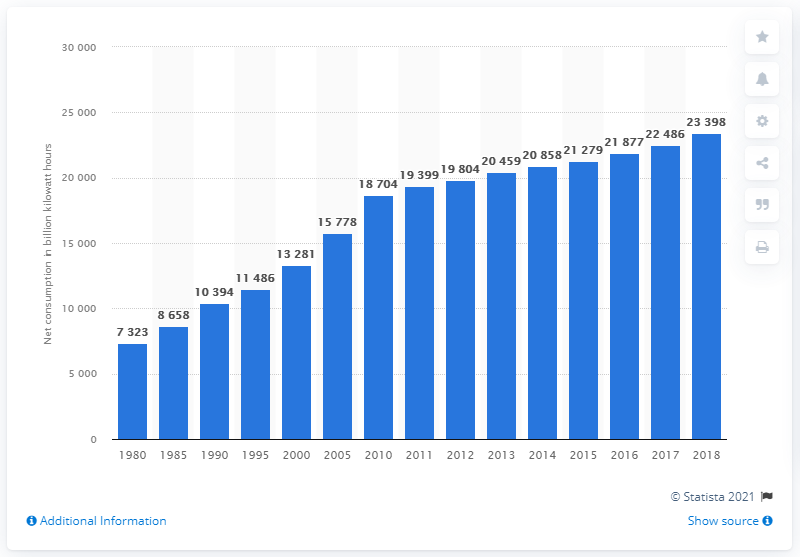How does the trend in the chart reflect changes in the energy sector? The trend in the chart highlights a shift towards higher electricity demand, which signals changes in the energy sector such as increased investment in electricity infrastructure, the development of renewable energy sources, and efforts to improve energy efficiency. It also suggests that there has been a diversification of energy sources used to generate electricity, adapting to the evolving needs of a growing and technologically advancing global population. 